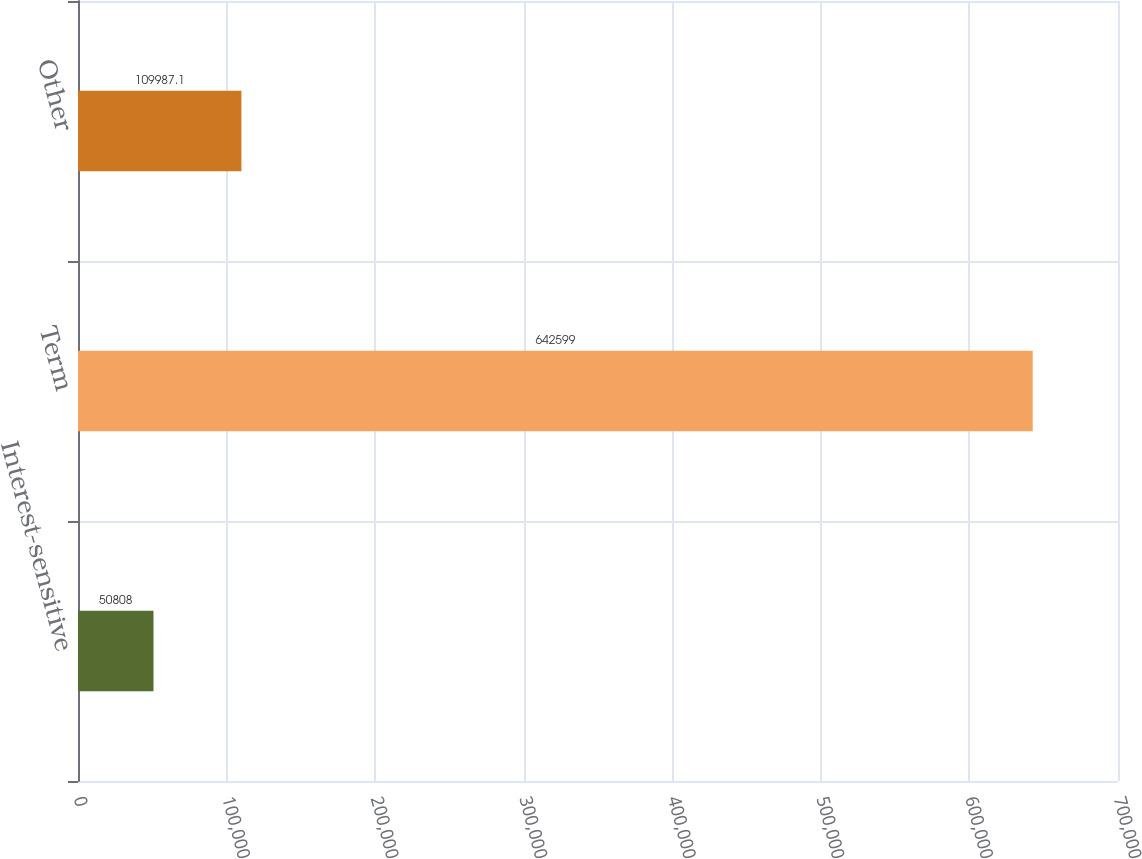Convert chart. <chart><loc_0><loc_0><loc_500><loc_500><bar_chart><fcel>Interest-sensitive<fcel>Term<fcel>Other<nl><fcel>50808<fcel>642599<fcel>109987<nl></chart> 